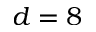<formula> <loc_0><loc_0><loc_500><loc_500>d = 8</formula> 